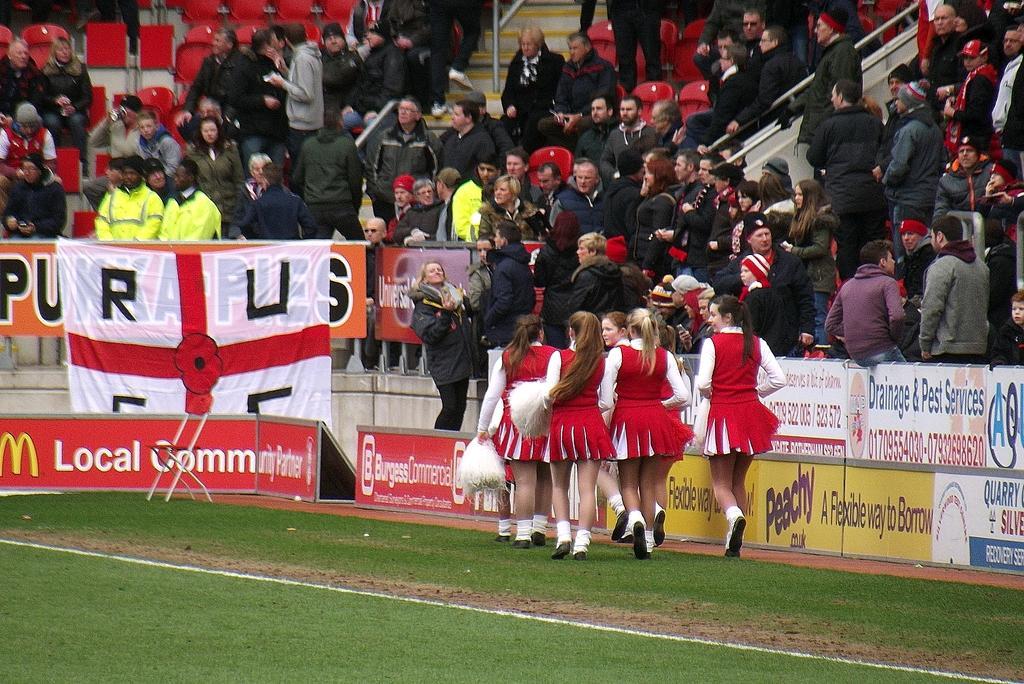Please provide a concise description of this image. This image is taken in a stadium. At the bottom of the image there is a ground with grass on it. In the middle of the image there are many boards with text on them and a few girls are walking on the ground and they are holding ping pongs in their hands. In the background many people are sitting on the chairs and a few are standing on the stairs. There are many empty chairs and there is a flag. 